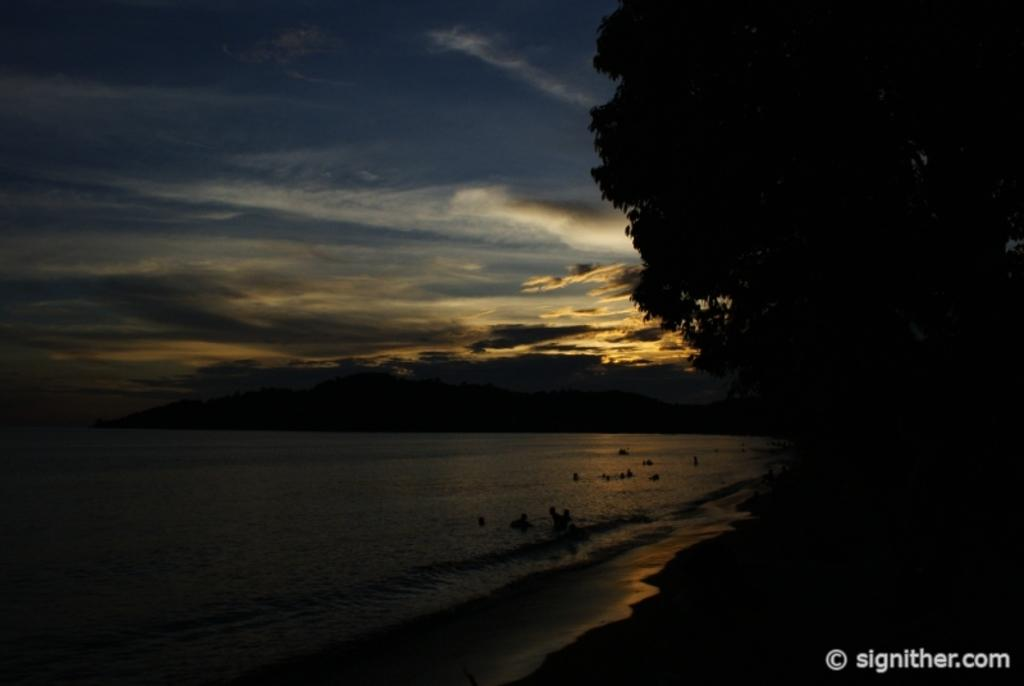What are the people in the image doing? The people in the image are in the water. What type of natural environment can be seen in the image? There are trees and mountains in the image. What is visible in the background of the image? The sky is visible in the background of the image. What can be observed in the sky? Clouds are present in the sky. What type of neck accessory is the person wearing in the image? There is no person wearing a neck accessory in the image, as it features people in the water with no visible clothing or accessories. 